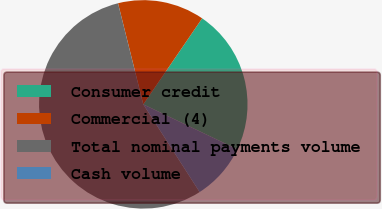Convert chart to OTSL. <chart><loc_0><loc_0><loc_500><loc_500><pie_chart><fcel>Consumer credit<fcel>Commercial (4)<fcel>Total nominal payments volume<fcel>Cash volume<nl><fcel>22.55%<fcel>13.45%<fcel>55.19%<fcel>8.81%<nl></chart> 